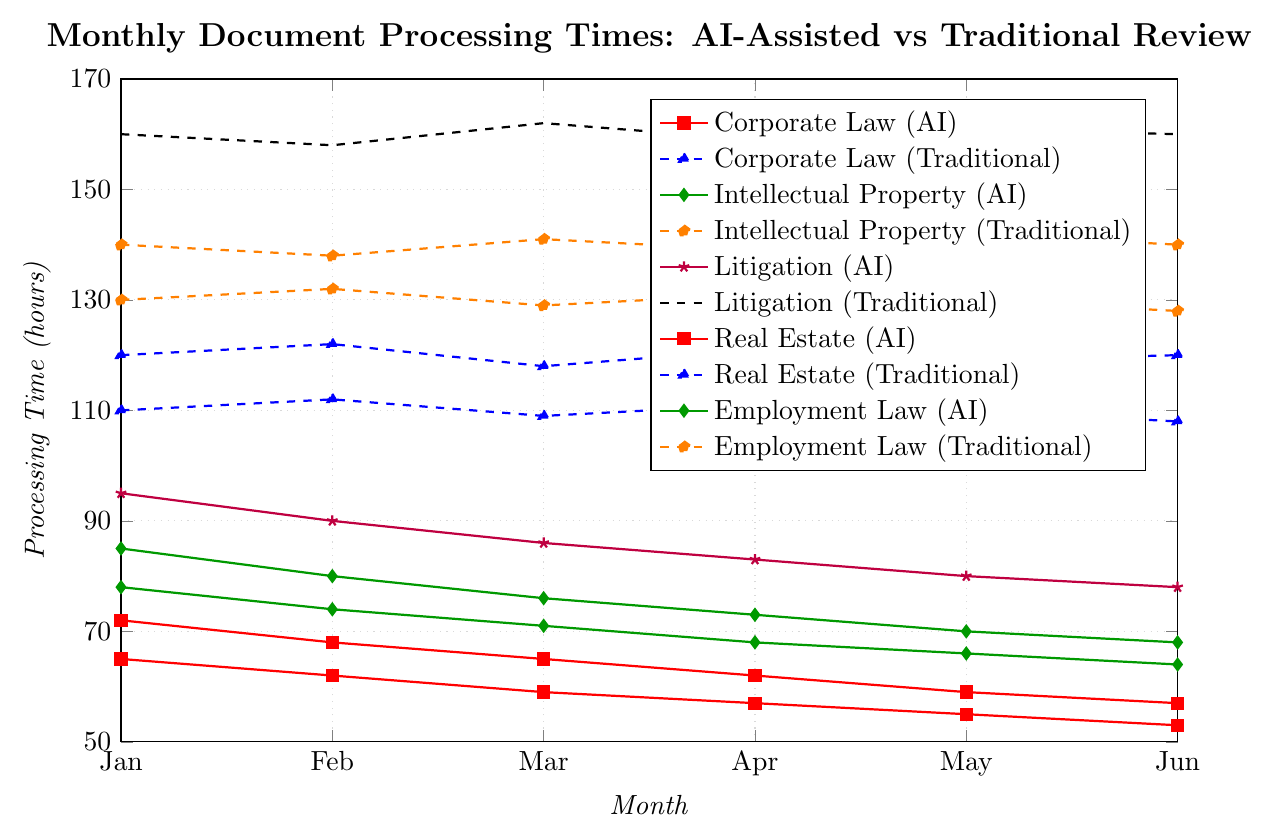What's the difference in processing time for Corporate Law between AI and traditional review in June? The "AI-Assisted Review" value for Corporate Law in June is 57, and the "Traditional Review" value is 120. The difference is 120 - 57 = 63.
Answer: 63 Which practice area shows the greatest difference between AI and traditional review processing times in January? By analyzing the values in January for each practice area, we have: Corporate Law (120-72=48), Intellectual Property (140-85=55), Litigation (160-95=65), Real Estate (110-65=45), Employment Law (130-78=52). The greatest difference is in the Litigation area with a difference of 65.
Answer: Litigation How does the trend in processing times for Employment Law with AI compare to that with traditional review from Jan to Jun? The processing time for AI decreases from 78 in Jan to 64 in Jun, showing a consistent downward trend. Meanwhile, the traditional review starts at 130 in Jan and decreases to 128 by Jun, which also shows a slight downward trend but less pronounced. Both methods show a decrease, with AI being more substantial.
Answer: AI shows a sharper decrease What is the average processing time reduction across all practice areas when using AI in June compared to traditional review? Calculate the difference for each practice area in June: Corporate Law (120-57=63), Intellectual Property (140-68=72), Litigation (160-78=82), Real Estate (108-53=55), Employment Law (128-64=64). The average is (63+72+82+55+64) / 5 = 67.2.
Answer: 67.2 For which month is the gap between AI and traditional review smallest in the Litigation area? In Litigation, the gaps are: Jan (160-95=65), Feb (158-90=68), Mar (162-86=76), Apr (159-83=76), May (161-80=81), Jun (160-78=82). The smallest gap is 65 in Jan.
Answer: January Which practice area shows the most consistent decrease in processing times from Jan to Jun with AI assistance? By observing the trends, Corporate Law (72 -> 57), Intellectual Property (85 -> 68), Litigation (95 -> 78), Real Estate (65 -> 53), Employment Law (78 -> 64). All show a consistent decrease, but Corporate Law and Real Estate show the most regular and consistent declines.
Answer: Real Estate What is the median processing time for traditional reviews across all practice areas in February? Traditional review times in February are: Corporate Law (122), Intellectual Property (138), Litigation (158), Real Estate (112), Employment Law (132). Sorting these values gives: 112, 122, 132, 138, 158. The median value is the middle one, 132.
Answer: 132 How much did processing times improve from Jan to Jun for Real Estate using AI assistance? For Real Estate, processing times with AI in Jan are 65 and in Jun are 53. The improvement is 65 - 53 = 12.
Answer: 12 Which review method (AI or traditional) shows more variation in processing times across months for Intellectual Property? The range for AI in Intellectual Property is from 85 in Jan to 68 in Jun (range = 85-68=17). The range for traditional review is from 142 in May to 138 in Feb (range = 142-138=4). Therefore, AI shows more variation.
Answer: AI Across all practice areas, which review method generally asserts lower processing times? By visual inspection of the trend lines, we see that all the AI-Assisted Review lines are generally lower than the Traditional Review lines.
Answer: AI 